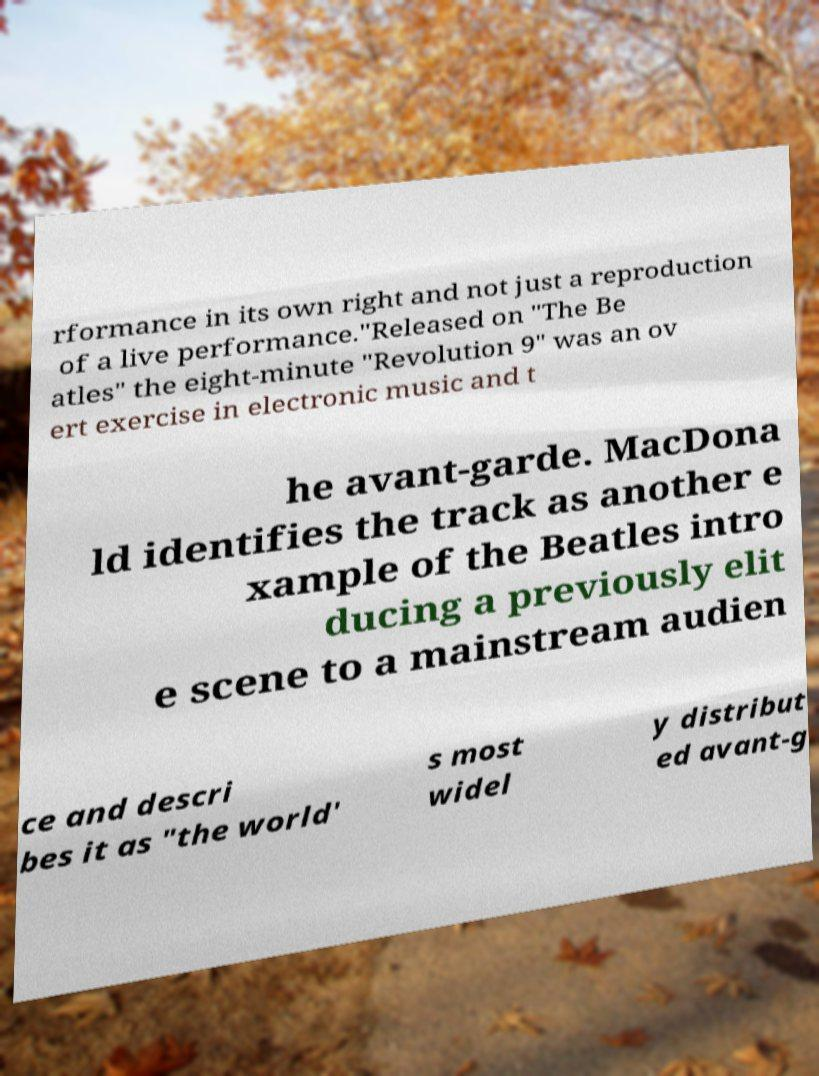Could you assist in decoding the text presented in this image and type it out clearly? rformance in its own right and not just a reproduction of a live performance."Released on "The Be atles" the eight-minute "Revolution 9" was an ov ert exercise in electronic music and t he avant-garde. MacDona ld identifies the track as another e xample of the Beatles intro ducing a previously elit e scene to a mainstream audien ce and descri bes it as "the world' s most widel y distribut ed avant-g 